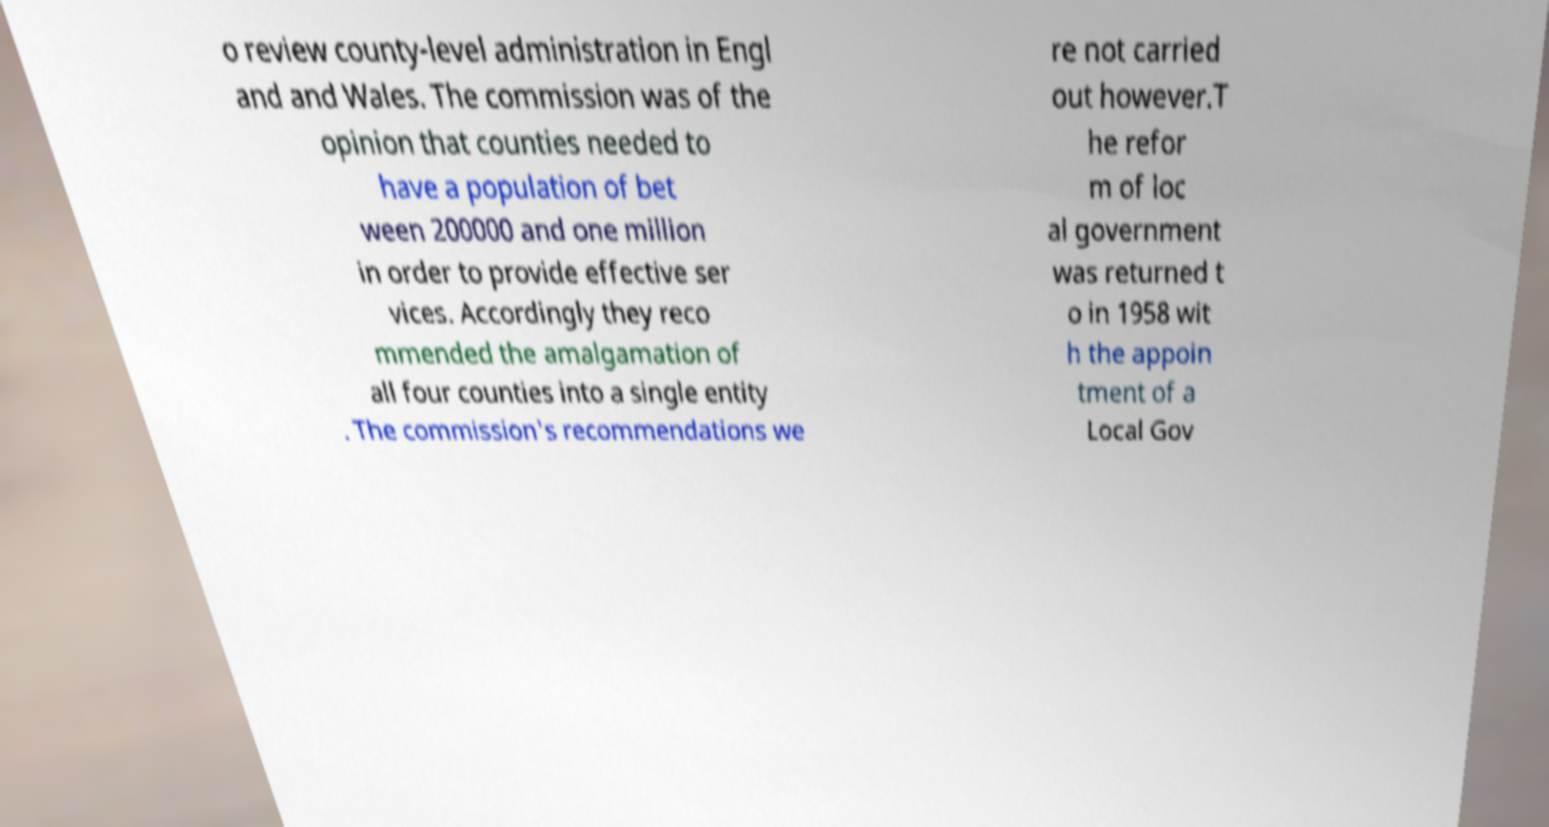Can you read and provide the text displayed in the image?This photo seems to have some interesting text. Can you extract and type it out for me? o review county-level administration in Engl and and Wales. The commission was of the opinion that counties needed to have a population of bet ween 200000 and one million in order to provide effective ser vices. Accordingly they reco mmended the amalgamation of all four counties into a single entity . The commission's recommendations we re not carried out however.T he refor m of loc al government was returned t o in 1958 wit h the appoin tment of a Local Gov 